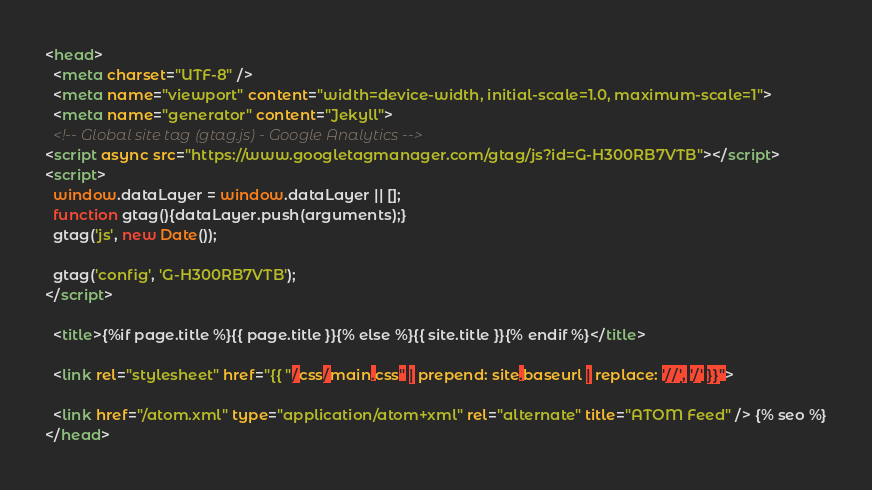<code> <loc_0><loc_0><loc_500><loc_500><_HTML_><head>
  <meta charset="UTF-8" />
  <meta name="viewport" content="width=device-width, initial-scale=1.0, maximum-scale=1">
  <meta name="generator" content="Jekyll">
  <!-- Global site tag (gtag.js) - Google Analytics -->
<script async src="https://www.googletagmanager.com/gtag/js?id=G-H300RB7VTB"></script>
<script>
  window.dataLayer = window.dataLayer || [];
  function gtag(){dataLayer.push(arguments);}
  gtag('js', new Date());

  gtag('config', 'G-H300RB7VTB');
</script>

  <title>{%if page.title %}{{ page.title }}{% else %}{{ site.title }}{% endif %}</title>

  <link rel="stylesheet" href="{{ "/css/main.css" | prepend: site.baseurl | replace: '//', '/' }}">
  
  <link href="/atom.xml" type="application/atom+xml" rel="alternate" title="ATOM Feed" /> {% seo %}
</head>
</code> 